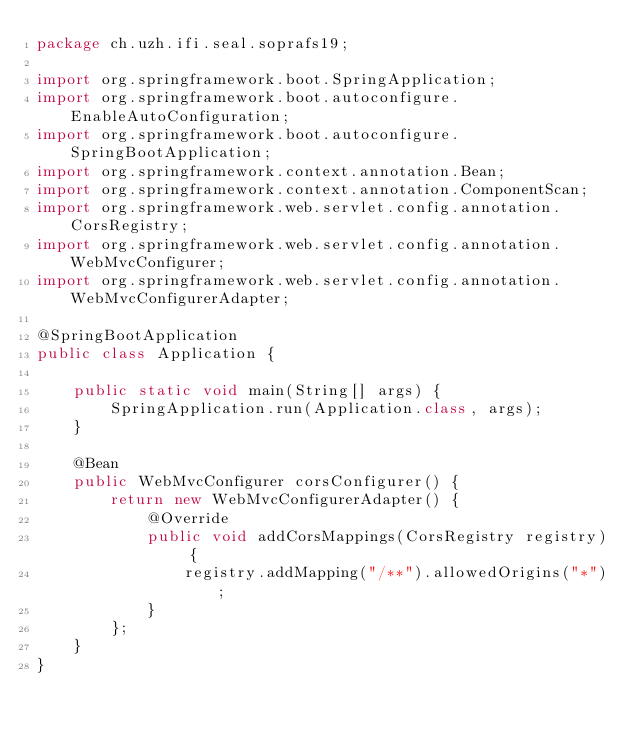Convert code to text. <code><loc_0><loc_0><loc_500><loc_500><_Java_>package ch.uzh.ifi.seal.soprafs19;

import org.springframework.boot.SpringApplication;
import org.springframework.boot.autoconfigure.EnableAutoConfiguration;
import org.springframework.boot.autoconfigure.SpringBootApplication;
import org.springframework.context.annotation.Bean;
import org.springframework.context.annotation.ComponentScan;
import org.springframework.web.servlet.config.annotation.CorsRegistry;
import org.springframework.web.servlet.config.annotation.WebMvcConfigurer;
import org.springframework.web.servlet.config.annotation.WebMvcConfigurerAdapter;

@SpringBootApplication
public class Application {

    public static void main(String[] args) {
        SpringApplication.run(Application.class, args);
    }

    @Bean
    public WebMvcConfigurer corsConfigurer() {
        return new WebMvcConfigurerAdapter() {
            @Override
            public void addCorsMappings(CorsRegistry registry) {
                registry.addMapping("/**").allowedOrigins("*");
            }
        };
    }
}
</code> 